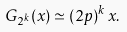Convert formula to latex. <formula><loc_0><loc_0><loc_500><loc_500>G _ { 2 ^ { k } } ( x ) \simeq ( 2 p ) ^ { k } \, x .</formula> 